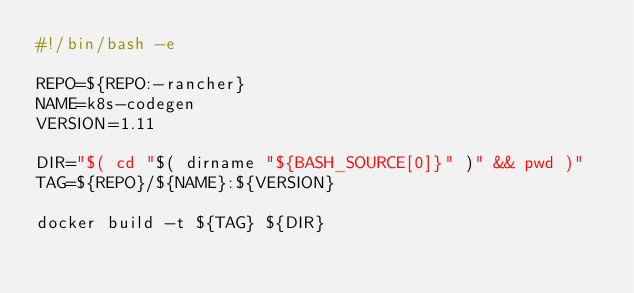Convert code to text. <code><loc_0><loc_0><loc_500><loc_500><_Bash_>#!/bin/bash -e

REPO=${REPO:-rancher}
NAME=k8s-codegen
VERSION=1.11

DIR="$( cd "$( dirname "${BASH_SOURCE[0]}" )" && pwd )"
TAG=${REPO}/${NAME}:${VERSION}

docker build -t ${TAG} ${DIR}

</code> 